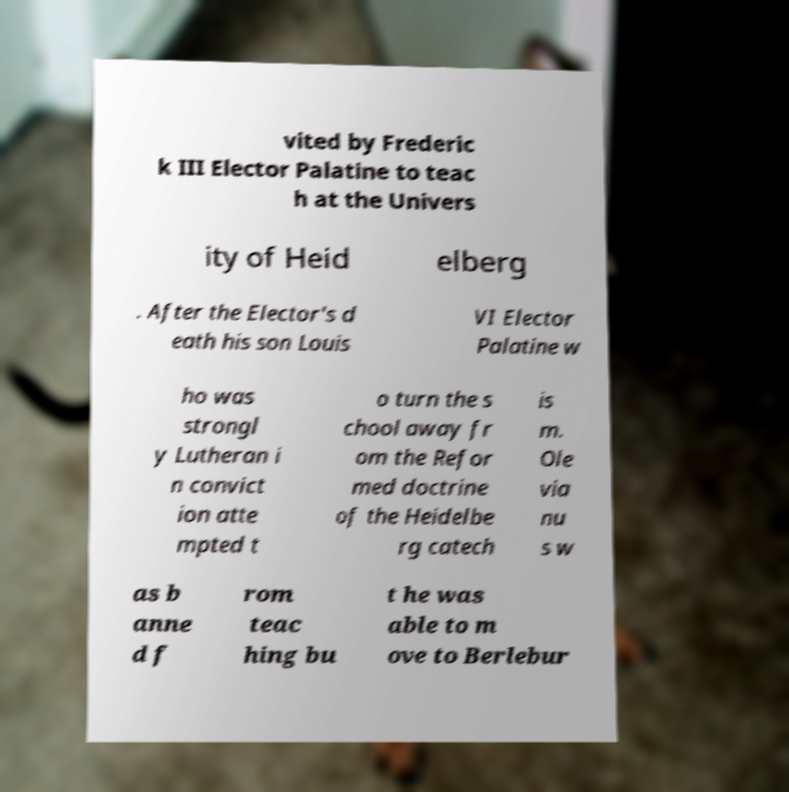Can you accurately transcribe the text from the provided image for me? vited by Frederic k III Elector Palatine to teac h at the Univers ity of Heid elberg . After the Elector's d eath his son Louis VI Elector Palatine w ho was strongl y Lutheran i n convict ion atte mpted t o turn the s chool away fr om the Refor med doctrine of the Heidelbe rg catech is m. Ole via nu s w as b anne d f rom teac hing bu t he was able to m ove to Berlebur 